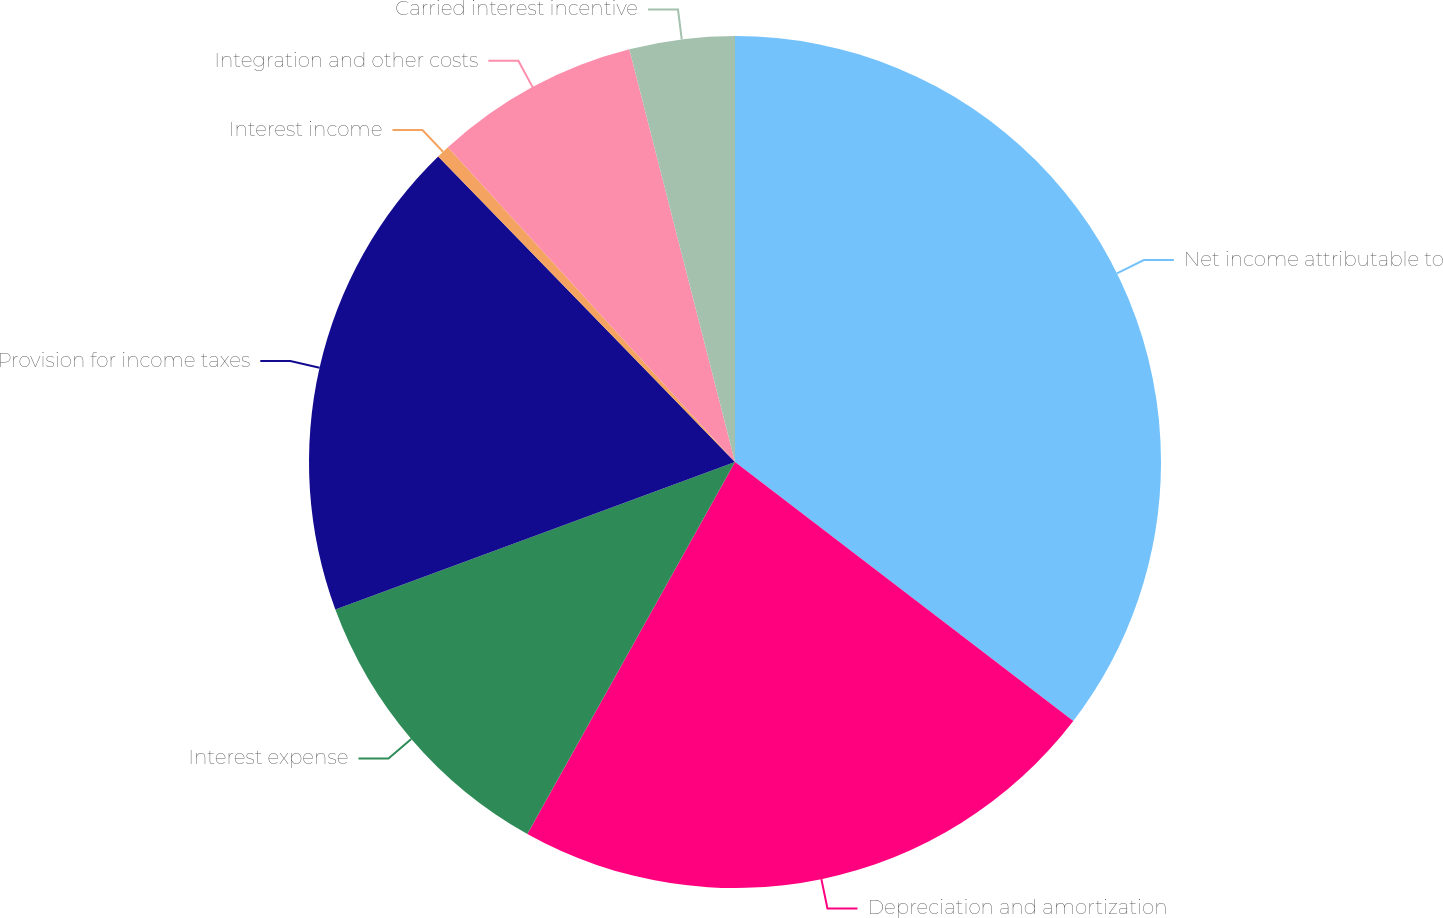Convert chart to OTSL. <chart><loc_0><loc_0><loc_500><loc_500><pie_chart><fcel>Net income attributable to<fcel>Depreciation and amortization<fcel>Interest expense<fcel>Provision for income taxes<fcel>Interest income<fcel>Integration and other costs<fcel>Carried interest incentive<nl><fcel>35.4%<fcel>22.71%<fcel>11.27%<fcel>18.36%<fcel>0.5%<fcel>7.78%<fcel>3.99%<nl></chart> 